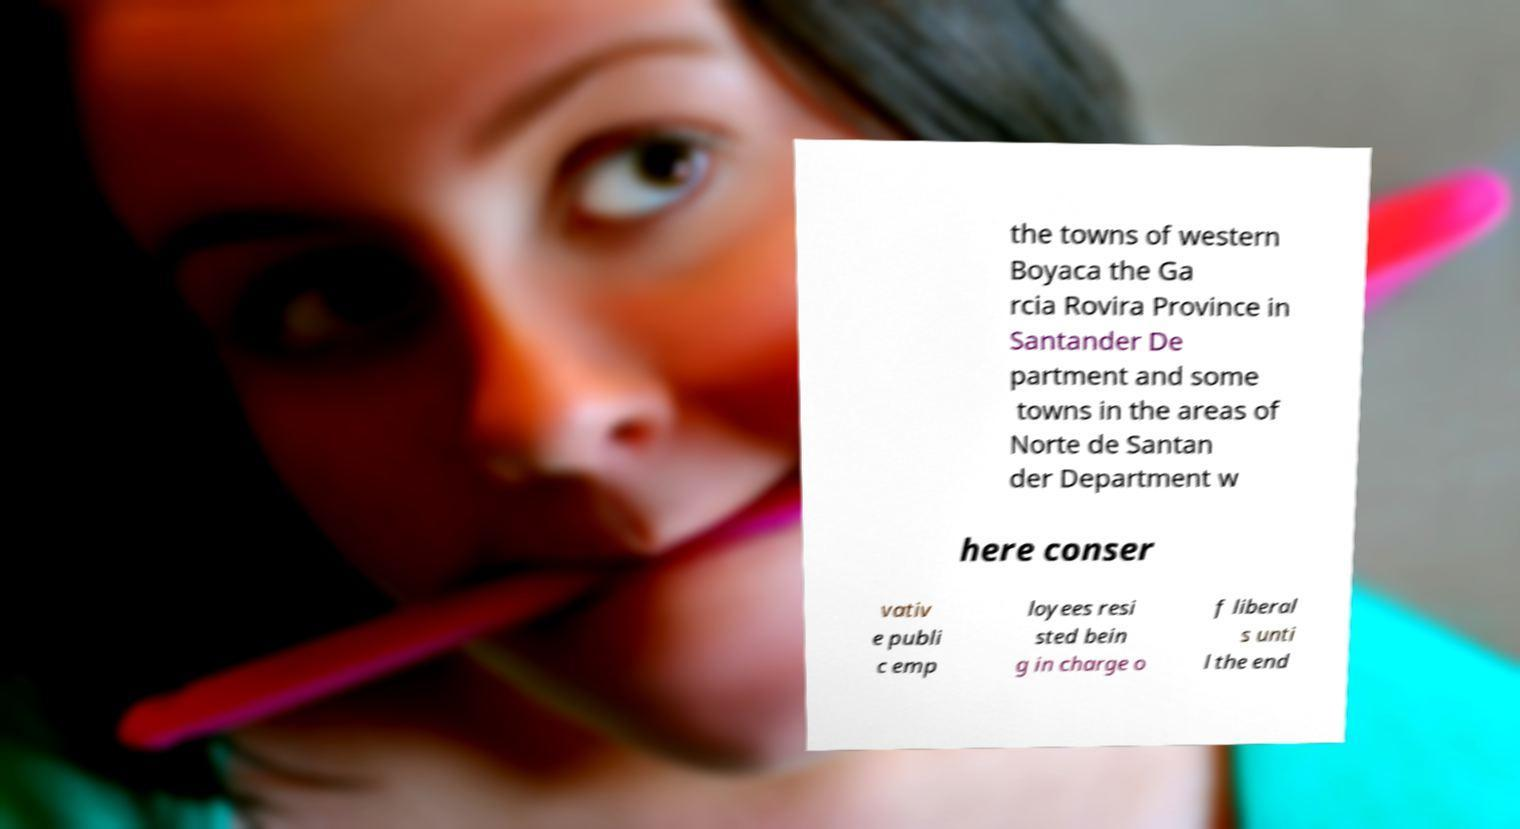For documentation purposes, I need the text within this image transcribed. Could you provide that? the towns of western Boyaca the Ga rcia Rovira Province in Santander De partment and some towns in the areas of Norte de Santan der Department w here conser vativ e publi c emp loyees resi sted bein g in charge o f liberal s unti l the end 